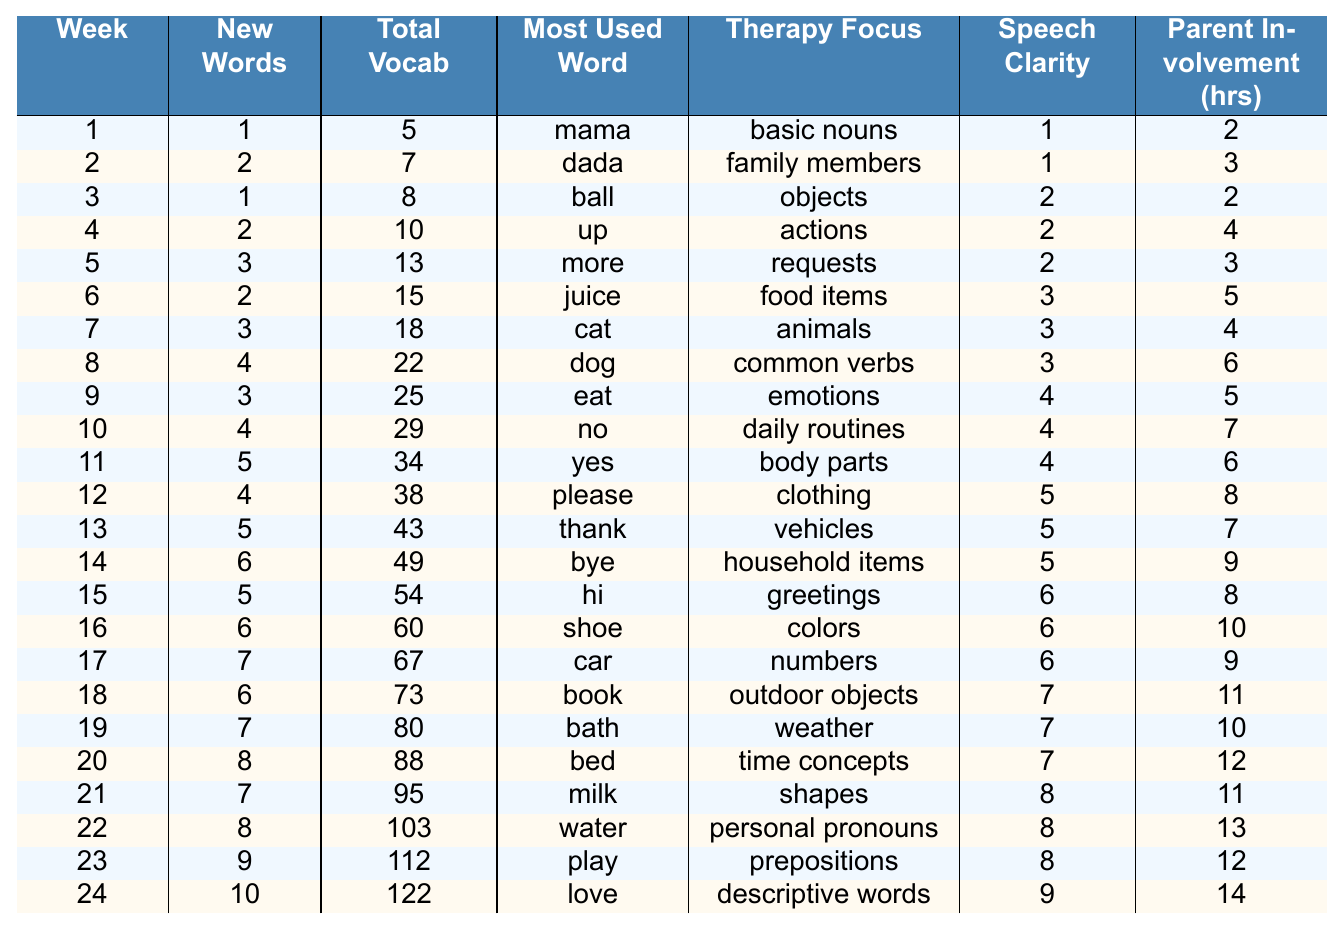What was the most used word in week 5? In week 5, the table shows the most used word is "more."
Answer: more How many new words were introduced in week 12? The data in week 12 indicates that 4 new words were introduced.
Answer: 4 What was the total vocabulary at the end of week 10? At the end of week 10, the total vocabulary is 29.
Answer: 29 Did the speech clarity improve from week 1 to week 6? Yes, speech clarity increased from 1 in week 1 to 3 in week 6.
Answer: Yes How many new words were introduced during the last four weeks? The new words in weeks 21 to 24 are 7, 8, 9, and 10 respectively. Adding these gives 7 + 8 + 9 + 10 = 34.
Answer: 34 Was "water" the most used word in week 22? No, "water" was the most used word in week 22 according to the table.
Answer: Yes What is the average number of new words learned per week over the entire period? The total new words learned across all weeks is 100 (sum of 1 to 10 over the 24 weeks). Dividing by the number of weeks (24) gives an average of 100 / 24 ≈ 4.17.
Answer: 4.17 How much did parent involvement hours increase from week 1 to week 24? In week 1, parent involvement was 2 hours, and in week 24, it was 14 hours. The increase is 14 - 2 = 12 hours.
Answer: 12 hours In which week did the most significant jump in total vocabulary occur? Reviewing total vocabulary, the most significant jump is from week 21 (95) to week 22 (103), a difference of 8.
Answer: Week 22 What was the therapy focus for week 17? In week 17, the therapy focus was on "numbers."
Answer: numbers Was there a week when six new words were learned? Yes, in week 14, six new words were learned.
Answer: Yes 